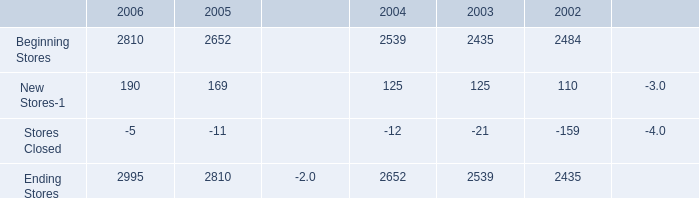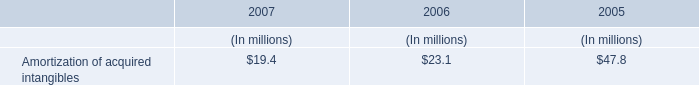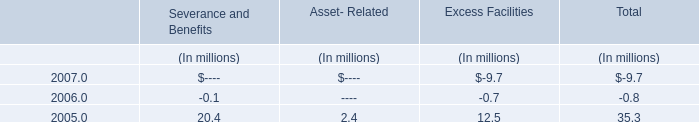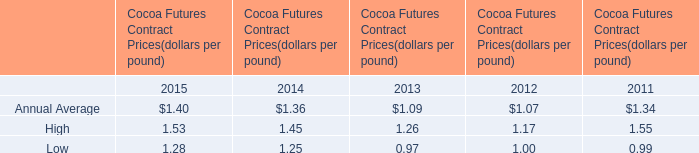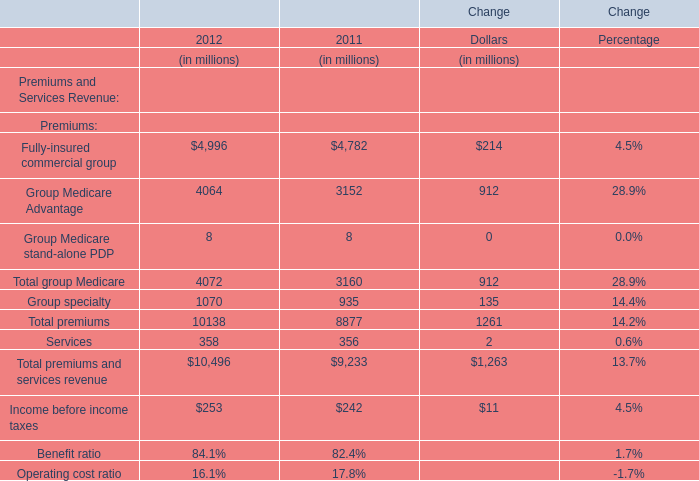What is the growing rate of Group specialty in the year with the most Total premiums? 
Computations: ((1070 - 935) / 1070)
Answer: 0.12617. 